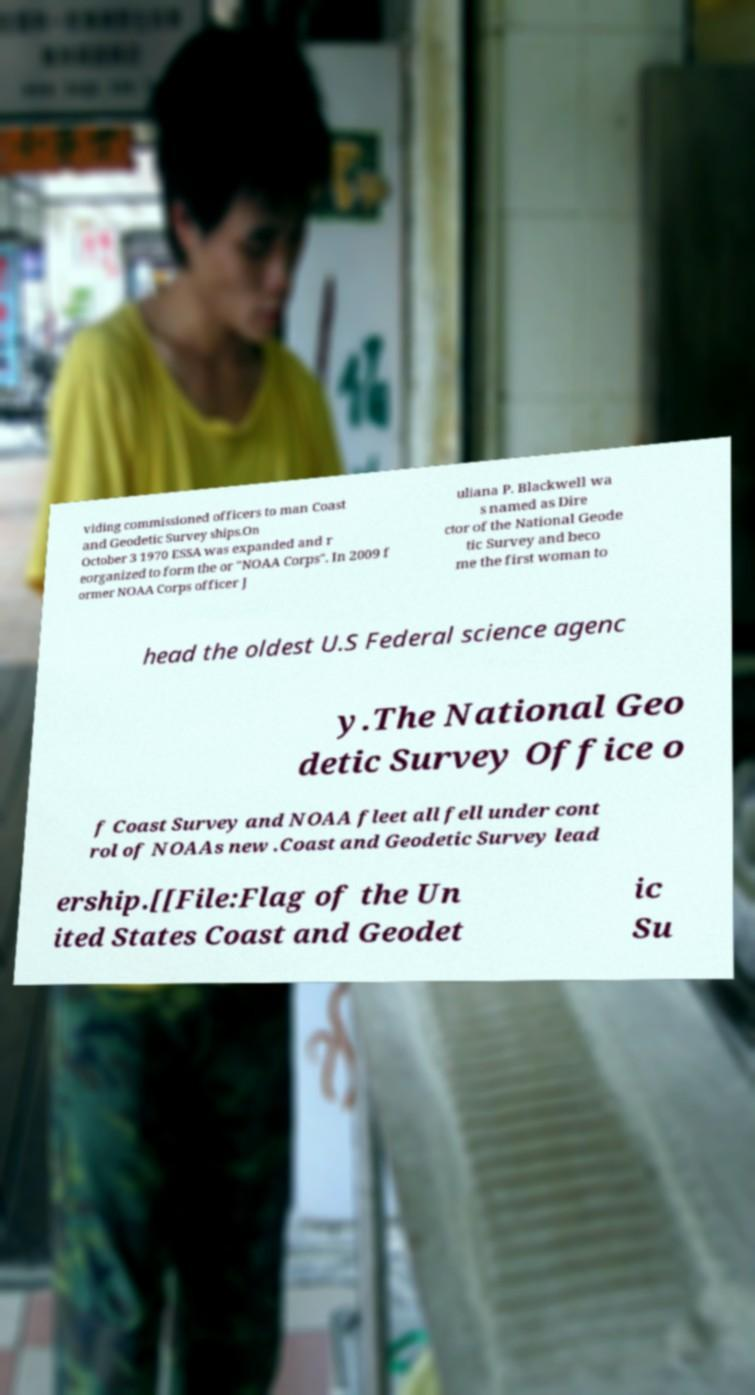For documentation purposes, I need the text within this image transcribed. Could you provide that? viding commissioned officers to man Coast and Geodetic Survey ships.On October 3 1970 ESSA was expanded and r eorganized to form the or "NOAA Corps". In 2009 f ormer NOAA Corps officer J uliana P. Blackwell wa s named as Dire ctor of the National Geode tic Survey and beco me the first woman to head the oldest U.S Federal science agenc y.The National Geo detic Survey Office o f Coast Survey and NOAA fleet all fell under cont rol of NOAAs new .Coast and Geodetic Survey lead ership.[[File:Flag of the Un ited States Coast and Geodet ic Su 